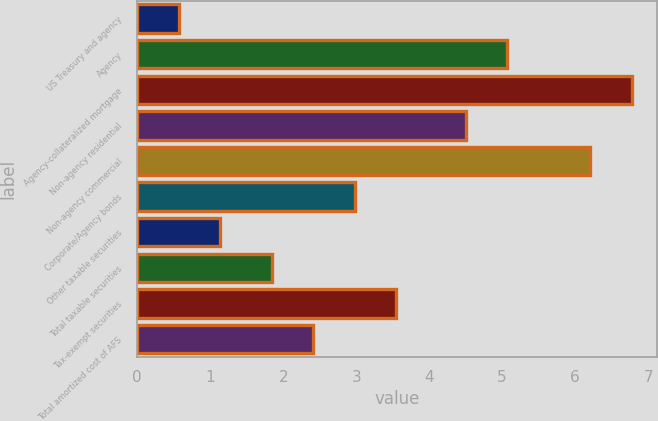<chart> <loc_0><loc_0><loc_500><loc_500><bar_chart><fcel>US Treasury and agency<fcel>Agency<fcel>Agency-collateralized mortgage<fcel>Non-agency residential<fcel>Non-agency commercial<fcel>Corporate/Agency bonds<fcel>Other taxable securities<fcel>Total taxable securities<fcel>Tax-exempt securities<fcel>Total amortized cost of AFS<nl><fcel>0.57<fcel>5.07<fcel>6.78<fcel>4.5<fcel>6.21<fcel>2.98<fcel>1.14<fcel>1.84<fcel>3.55<fcel>2.41<nl></chart> 